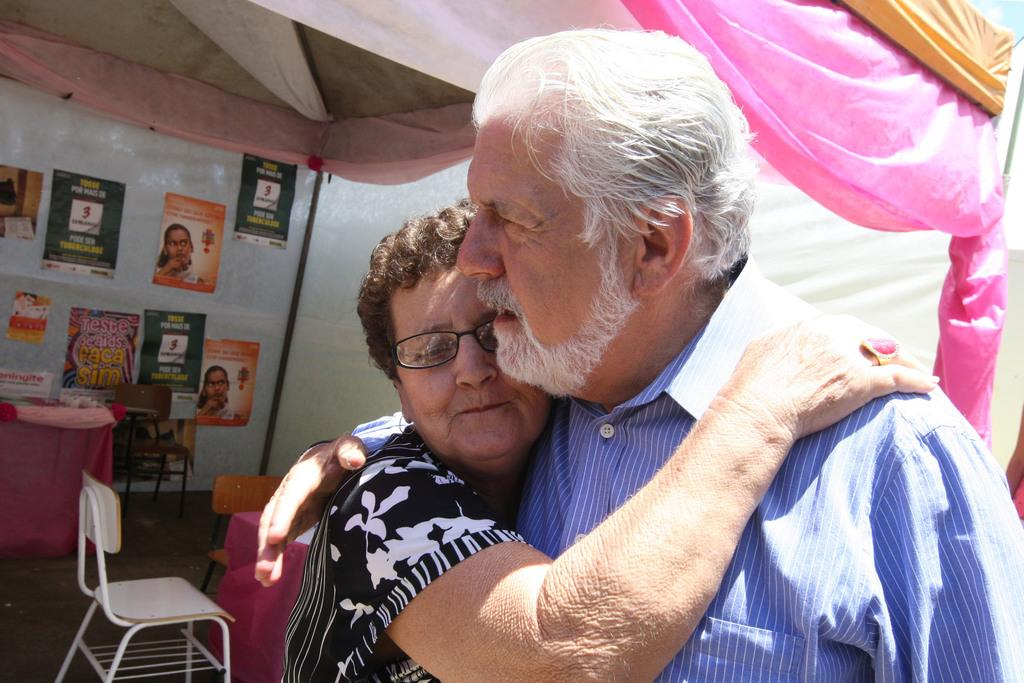How many people are in the image? There are two persons in the image. What are the two persons doing? The two persons are hugging each other. What can be seen in the background of the image? There are posters in the background of the image. What type of toothbrush is visible on the floor in the image? There is no toothbrush present in the image, and the floor is not mentioned in the provided facts. 